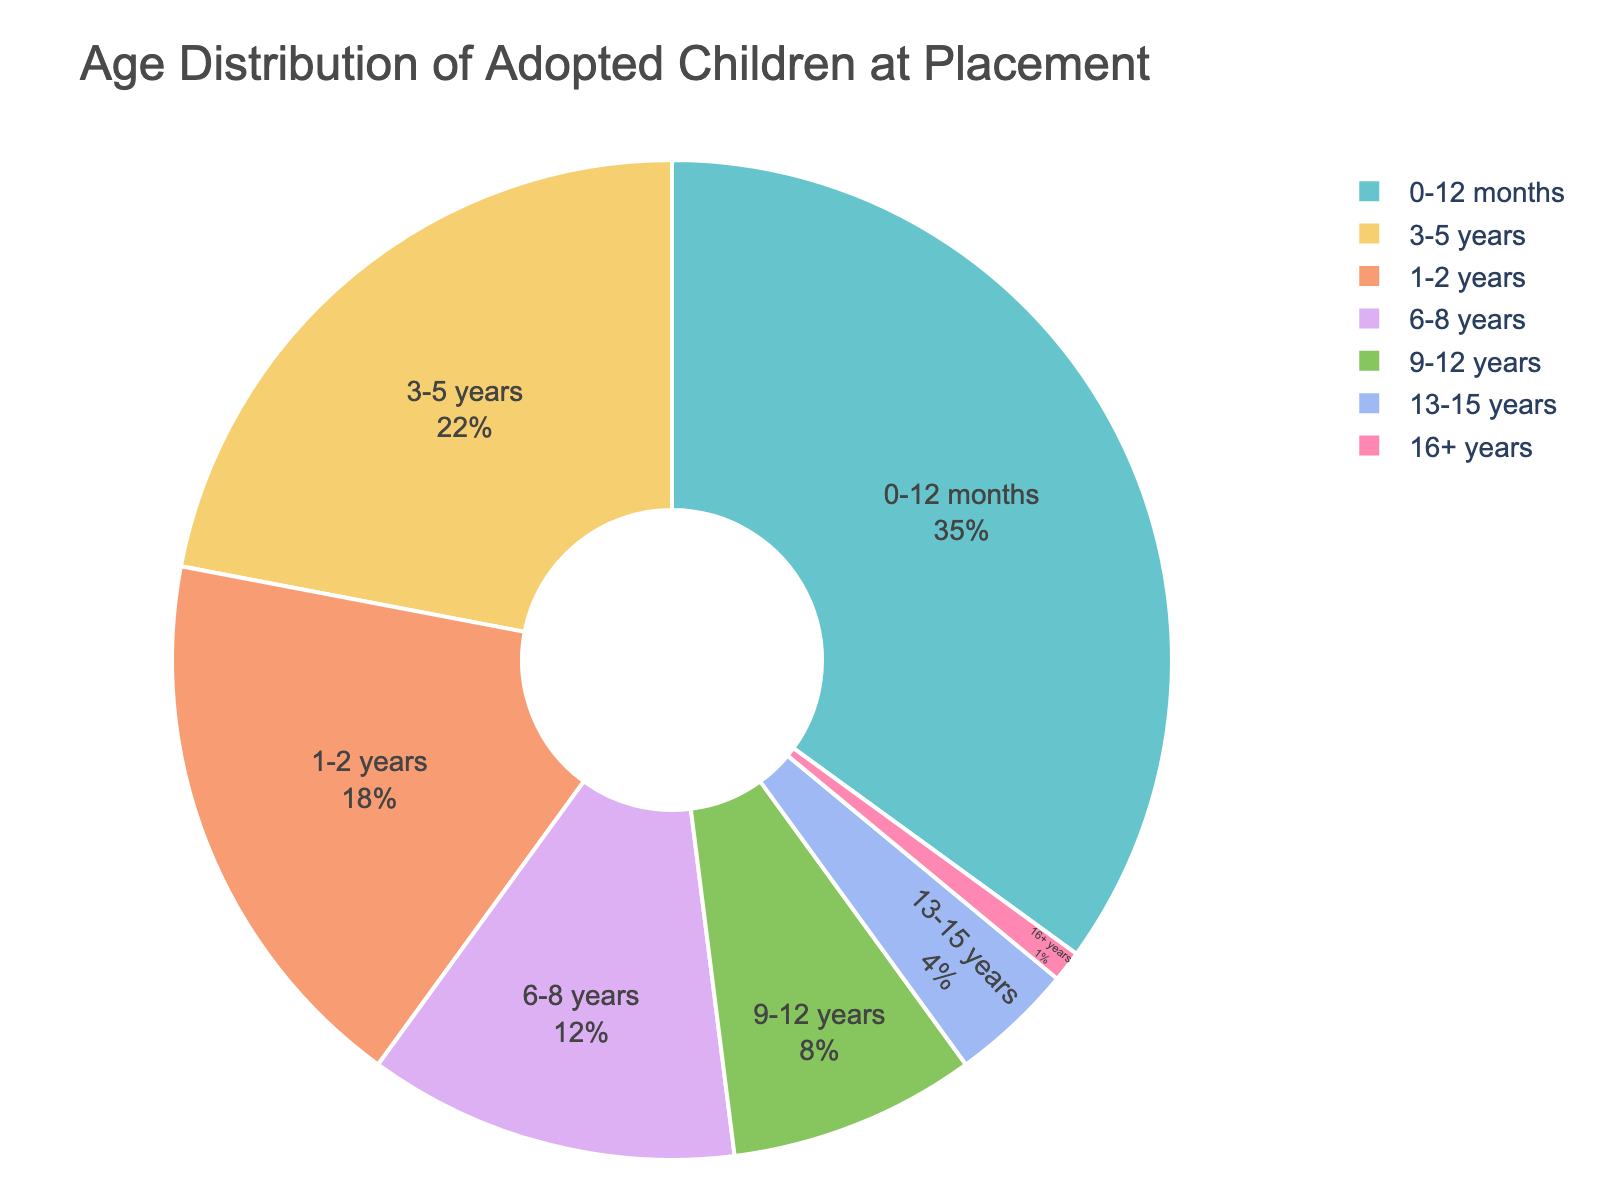What age group has the highest percentage of adopted children at the time of placement? Looking at the pie chart, we need to identify the age group with the largest segment, which is the one with the highest percentage.
Answer: 0-12 months Which is smaller, the percentage of children adopted between ages 1-2 years or those adopted between ages 6-8 years? By comparing the segments of the two age groups, we see that 1-2 years has an 18% slice, and 6-8 years has a 12% slice. Therefore, 6-8 years is smaller.
Answer: 6-8 years Approximately what percentage of adopted children are aged 9 years or older? To find the combined percentage, add the percentages for the age groups 9-12 years (8%), 13-15 years (4%), and 16+ years (1%) together. This sums to 8 + 4 + 1 = 13%.
Answer: 13% Is the percentage of children adopted at age 3-5 years greater than or equal to the sum of those adopted from ages 9-15 years? First, check the 3-5 years slice, which has 22%. Then, add the slices for 9-12 years (8%) and 13-15 years (4%), giving a total of 8 + 4 = 12%. Since 22% is greater than 12%, the answer is yes.
Answer: Yes How much greater is the percentage of children adopted at 0-12 months compared to those adopted at 1-2 years? The percentage for 0-12 months is 35%, and the percentage for 1-2 years is 18%. The difference is 35 - 18 = 17%.
Answer: 17% What proportion of adopted children are aged 6 years or older? Add the percentages for 6-8 years (12%), 9-12 years (8%), 13-15 years (4%), and 16+ years (1%). This totals 12 + 8 + 4 + 1 = 25%.
Answer: 25% How does the percentage of children adopted between ages 3-5 years compare to those adopted at 6-8 years? The age group 3-5 years has a 22% slice, while 6-8 years has a 12% slice. Therefore, 3-5 years has a higher percentage.
Answer: 3-5 years is higher Which age group represents the smallest percentage of adopted children at the time of placement? Identify the smallest slice in the pie chart, which corresponds to the age group 16+ years with 1%.
Answer: 16+ years What is the difference between the percentage of children adopted between ages 3-5 years and those adopted between ages 9-12 years? The percentage for 3-5 years is 22%, and for 9-12 years is 8%. The difference is 22 - 8 = 14%.
Answer: 14% 